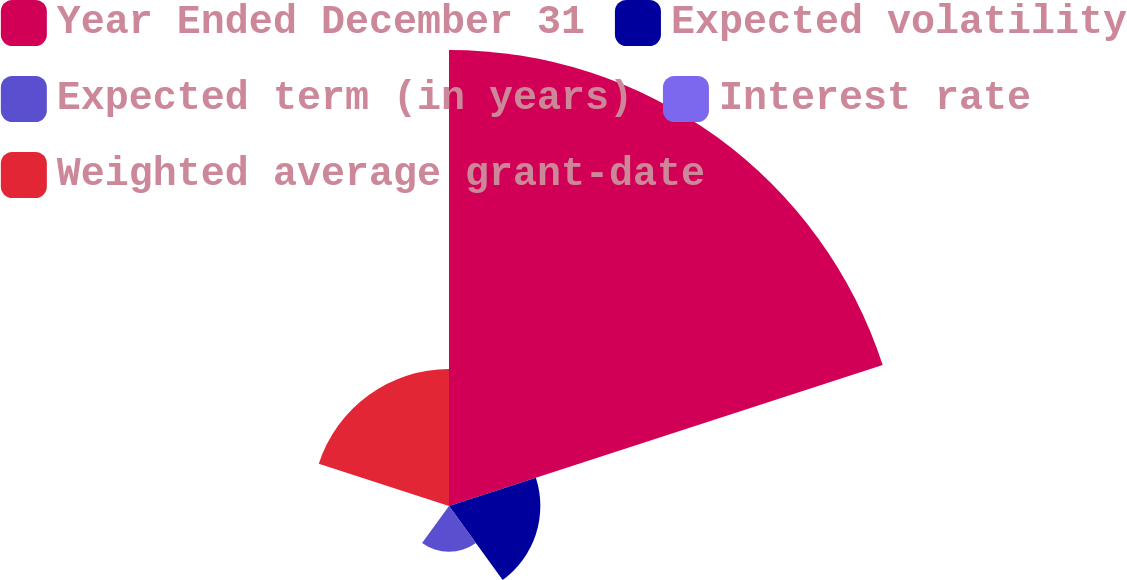<chart> <loc_0><loc_0><loc_500><loc_500><pie_chart><fcel>Year Ended December 31<fcel>Expected volatility<fcel>Expected term (in years)<fcel>Interest rate<fcel>Weighted average grant-date<nl><fcel>62.45%<fcel>12.51%<fcel>6.27%<fcel>0.02%<fcel>18.75%<nl></chart> 